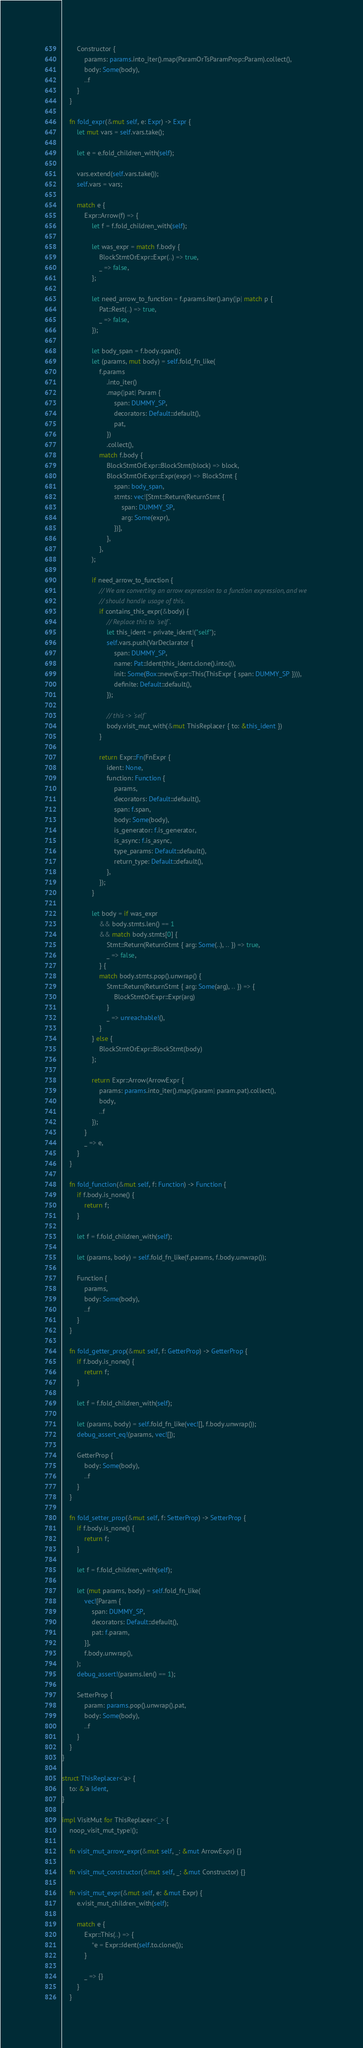Convert code to text. <code><loc_0><loc_0><loc_500><loc_500><_Rust_>        Constructor {
            params: params.into_iter().map(ParamOrTsParamProp::Param).collect(),
            body: Some(body),
            ..f
        }
    }

    fn fold_expr(&mut self, e: Expr) -> Expr {
        let mut vars = self.vars.take();

        let e = e.fold_children_with(self);

        vars.extend(self.vars.take());
        self.vars = vars;

        match e {
            Expr::Arrow(f) => {
                let f = f.fold_children_with(self);

                let was_expr = match f.body {
                    BlockStmtOrExpr::Expr(..) => true,
                    _ => false,
                };

                let need_arrow_to_function = f.params.iter().any(|p| match p {
                    Pat::Rest(..) => true,
                    _ => false,
                });

                let body_span = f.body.span();
                let (params, mut body) = self.fold_fn_like(
                    f.params
                        .into_iter()
                        .map(|pat| Param {
                            span: DUMMY_SP,
                            decorators: Default::default(),
                            pat,
                        })
                        .collect(),
                    match f.body {
                        BlockStmtOrExpr::BlockStmt(block) => block,
                        BlockStmtOrExpr::Expr(expr) => BlockStmt {
                            span: body_span,
                            stmts: vec![Stmt::Return(ReturnStmt {
                                span: DUMMY_SP,
                                arg: Some(expr),
                            })],
                        },
                    },
                );

                if need_arrow_to_function {
                    // We are converting an arrow expression to a function expression, and we
                    // should handle usage of this.
                    if contains_this_expr(&body) {
                        // Replace this to `self`.
                        let this_ident = private_ident!("self");
                        self.vars.push(VarDeclarator {
                            span: DUMMY_SP,
                            name: Pat::Ident(this_ident.clone().into()),
                            init: Some(Box::new(Expr::This(ThisExpr { span: DUMMY_SP }))),
                            definite: Default::default(),
                        });

                        // this -> `self`
                        body.visit_mut_with(&mut ThisReplacer { to: &this_ident })
                    }

                    return Expr::Fn(FnExpr {
                        ident: None,
                        function: Function {
                            params,
                            decorators: Default::default(),
                            span: f.span,
                            body: Some(body),
                            is_generator: f.is_generator,
                            is_async: f.is_async,
                            type_params: Default::default(),
                            return_type: Default::default(),
                        },
                    });
                }

                let body = if was_expr
                    && body.stmts.len() == 1
                    && match body.stmts[0] {
                        Stmt::Return(ReturnStmt { arg: Some(..), .. }) => true,
                        _ => false,
                    } {
                    match body.stmts.pop().unwrap() {
                        Stmt::Return(ReturnStmt { arg: Some(arg), .. }) => {
                            BlockStmtOrExpr::Expr(arg)
                        }
                        _ => unreachable!(),
                    }
                } else {
                    BlockStmtOrExpr::BlockStmt(body)
                };

                return Expr::Arrow(ArrowExpr {
                    params: params.into_iter().map(|param| param.pat).collect(),
                    body,
                    ..f
                });
            }
            _ => e,
        }
    }

    fn fold_function(&mut self, f: Function) -> Function {
        if f.body.is_none() {
            return f;
        }

        let f = f.fold_children_with(self);

        let (params, body) = self.fold_fn_like(f.params, f.body.unwrap());

        Function {
            params,
            body: Some(body),
            ..f
        }
    }

    fn fold_getter_prop(&mut self, f: GetterProp) -> GetterProp {
        if f.body.is_none() {
            return f;
        }

        let f = f.fold_children_with(self);

        let (params, body) = self.fold_fn_like(vec![], f.body.unwrap());
        debug_assert_eq!(params, vec![]);

        GetterProp {
            body: Some(body),
            ..f
        }
    }

    fn fold_setter_prop(&mut self, f: SetterProp) -> SetterProp {
        if f.body.is_none() {
            return f;
        }

        let f = f.fold_children_with(self);

        let (mut params, body) = self.fold_fn_like(
            vec![Param {
                span: DUMMY_SP,
                decorators: Default::default(),
                pat: f.param,
            }],
            f.body.unwrap(),
        );
        debug_assert!(params.len() == 1);

        SetterProp {
            param: params.pop().unwrap().pat,
            body: Some(body),
            ..f
        }
    }
}

struct ThisReplacer<'a> {
    to: &'a Ident,
}

impl VisitMut for ThisReplacer<'_> {
    noop_visit_mut_type!();

    fn visit_mut_arrow_expr(&mut self, _: &mut ArrowExpr) {}

    fn visit_mut_constructor(&mut self, _: &mut Constructor) {}

    fn visit_mut_expr(&mut self, e: &mut Expr) {
        e.visit_mut_children_with(self);

        match e {
            Expr::This(..) => {
                *e = Expr::Ident(self.to.clone());
            }

            _ => {}
        }
    }
</code> 